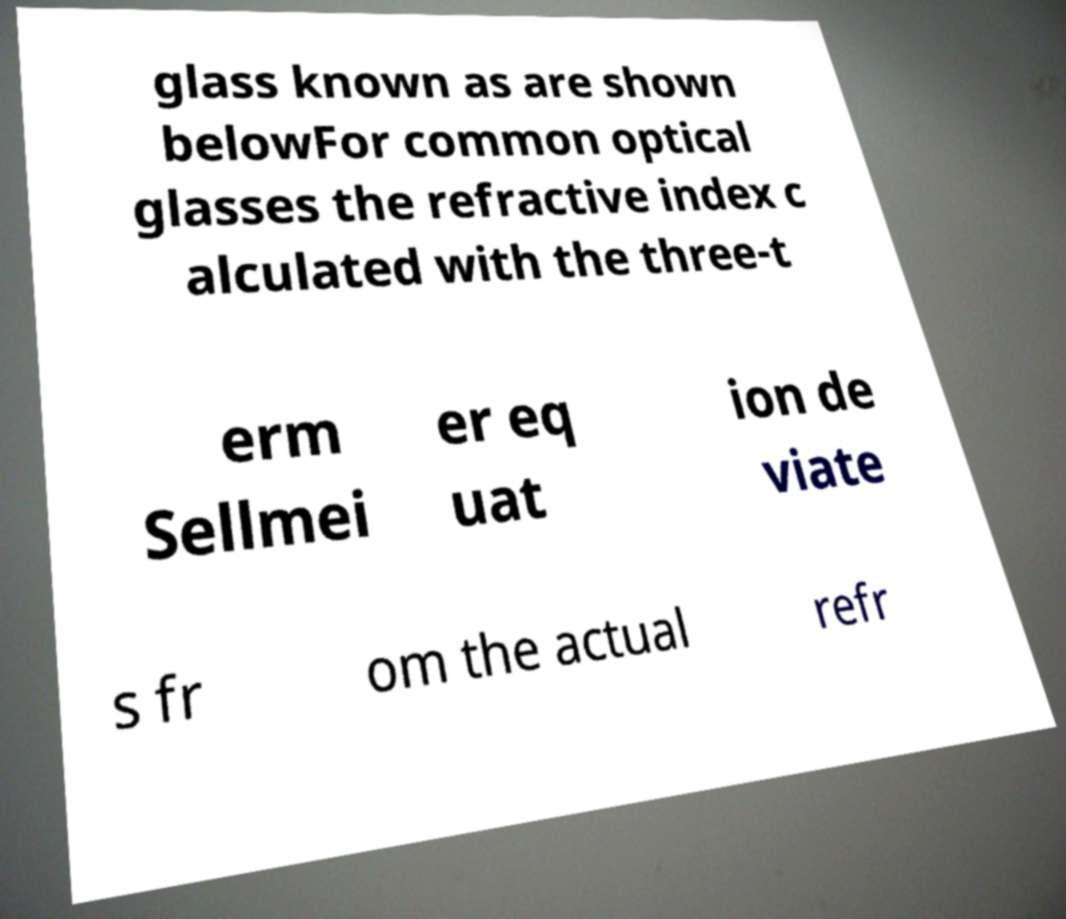I need the written content from this picture converted into text. Can you do that? glass known as are shown belowFor common optical glasses the refractive index c alculated with the three-t erm Sellmei er eq uat ion de viate s fr om the actual refr 